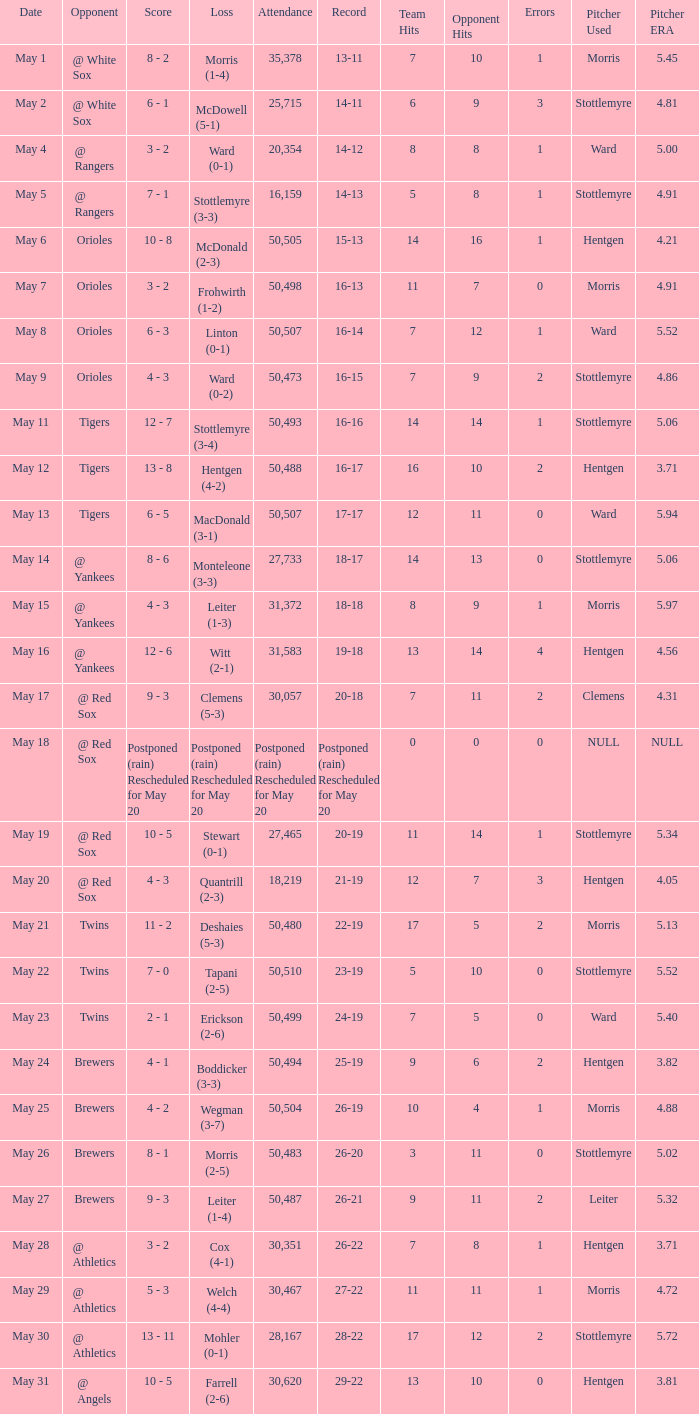On what date was their record 26-19? May 25. Can you parse all the data within this table? {'header': ['Date', 'Opponent', 'Score', 'Loss', 'Attendance', 'Record', 'Team Hits', 'Opponent Hits', 'Errors', 'Pitcher Used', 'Pitcher ERA'], 'rows': [['May 1', '@ White Sox', '8 - 2', 'Morris (1-4)', '35,378', '13-11', '7', '10', '1', 'Morris', '5.45'], ['May 2', '@ White Sox', '6 - 1', 'McDowell (5-1)', '25,715', '14-11', '6', '9', '3', 'Stottlemyre', '4.81'], ['May 4', '@ Rangers', '3 - 2', 'Ward (0-1)', '20,354', '14-12', '8', '8', '1', 'Ward', '5.00'], ['May 5', '@ Rangers', '7 - 1', 'Stottlemyre (3-3)', '16,159', '14-13', '5', '8', '1', 'Stottlemyre', '4.91'], ['May 6', 'Orioles', '10 - 8', 'McDonald (2-3)', '50,505', '15-13', '14', '16', '1', 'Hentgen', '4.21'], ['May 7', 'Orioles', '3 - 2', 'Frohwirth (1-2)', '50,498', '16-13', '11', '7', '0', 'Morris', '4.91'], ['May 8', 'Orioles', '6 - 3', 'Linton (0-1)', '50,507', '16-14', '7', '12', '1', 'Ward', '5.52'], ['May 9', 'Orioles', '4 - 3', 'Ward (0-2)', '50,473', '16-15', '7', '9', '2', 'Stottlemyre', '4.86'], ['May 11', 'Tigers', '12 - 7', 'Stottlemyre (3-4)', '50,493', '16-16', '14', '14', '1', 'Stottlemyre', '5.06'], ['May 12', 'Tigers', '13 - 8', 'Hentgen (4-2)', '50,488', '16-17', '16', '10', '2', 'Hentgen', '3.71'], ['May 13', 'Tigers', '6 - 5', 'MacDonald (3-1)', '50,507', '17-17', '12', '11', '0', 'Ward', '5.94'], ['May 14', '@ Yankees', '8 - 6', 'Monteleone (3-3)', '27,733', '18-17', '14', '13', '0', 'Stottlemyre', '5.06'], ['May 15', '@ Yankees', '4 - 3', 'Leiter (1-3)', '31,372', '18-18', '8', '9', '1', 'Morris', '5.97'], ['May 16', '@ Yankees', '12 - 6', 'Witt (2-1)', '31,583', '19-18', '13', '14', '4', 'Hentgen', '4.56'], ['May 17', '@ Red Sox', '9 - 3', 'Clemens (5-3)', '30,057', '20-18', '7', '11', '2', 'Clemens', '4.31'], ['May 18', '@ Red Sox', 'Postponed (rain) Rescheduled for May 20', 'Postponed (rain) Rescheduled for May 20', 'Postponed (rain) Rescheduled for May 20', 'Postponed (rain) Rescheduled for May 20', '0', '0', '0', 'NULL', 'NULL'], ['May 19', '@ Red Sox', '10 - 5', 'Stewart (0-1)', '27,465', '20-19', '11', '14', '1', 'Stottlemyre', '5.34'], ['May 20', '@ Red Sox', '4 - 3', 'Quantrill (2-3)', '18,219', '21-19', '12', '7', '3', 'Hentgen', '4.05'], ['May 21', 'Twins', '11 - 2', 'Deshaies (5-3)', '50,480', '22-19', '17', '5', '2', 'Morris', '5.13'], ['May 22', 'Twins', '7 - 0', 'Tapani (2-5)', '50,510', '23-19', '5', '10', '0', 'Stottlemyre', '5.52'], ['May 23', 'Twins', '2 - 1', 'Erickson (2-6)', '50,499', '24-19', '7', '5', '0', 'Ward', '5.40'], ['May 24', 'Brewers', '4 - 1', 'Boddicker (3-3)', '50,494', '25-19', '9', '6', '2', 'Hentgen', '3.82'], ['May 25', 'Brewers', '4 - 2', 'Wegman (3-7)', '50,504', '26-19', '10', '4', '1', 'Morris', '4.88'], ['May 26', 'Brewers', '8 - 1', 'Morris (2-5)', '50,483', '26-20', '3', '11', '0', 'Stottlemyre', '5.02'], ['May 27', 'Brewers', '9 - 3', 'Leiter (1-4)', '50,487', '26-21', '9', '11', '2', 'Leiter', '5.32'], ['May 28', '@ Athletics', '3 - 2', 'Cox (4-1)', '30,351', '26-22', '7', '8', '1', 'Hentgen', '3.71'], ['May 29', '@ Athletics', '5 - 3', 'Welch (4-4)', '30,467', '27-22', '11', '11', '1', 'Morris', '4.72'], ['May 30', '@ Athletics', '13 - 11', 'Mohler (0-1)', '28,167', '28-22', '17', '12', '2', 'Stottlemyre', '5.72'], ['May 31', '@ Angels', '10 - 5', 'Farrell (2-6)', '30,620', '29-22', '13', '10', '0', 'Hentgen', '3.81']]} 